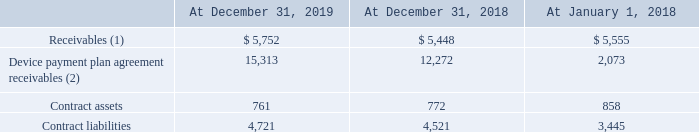Accounts receivable and contract balances
The timing of revenue recognition may differ from the time of billing to customers. Receivables presented in the balance sheet represent an unconditional right to consideration.
Contract balances represent amounts from an arrangement when either the performance obligation has been satisfied by transferring goods and/or services to the customer in advance of receiving all or partial consideration for such goods and/or services from the customer, or the customer has made payment in advance of obtaining control of the goods and/or services promised to the customer in the contract.
Contract assets primarily relate to rights to consideration for goods and/or services provided to the customers but for which there is not an unconditional right at the reporting date. Under a fixed-term plan, the total contract revenue is allocated between wireless services and equipment revenues, as discussed above.
In conjunction with these arrangements, a contract asset is created, which represents the difference between the amount of equipment revenue recognized upon sale and the amount of consideration received from the customer. The contract asset is recognized as accounts receivable as wireless services are provided and billed. The right to bill the customer is

obtained as service is provided over time, which results in the right to the payment being unconditional.
The contract asset balances are presented in the balance sheets as prepaid expenses and other, and other assets - net. Contract assets are assessed for impairment on an annual basis and an impairment charge is recognized to the extent the carrying amount is not recoverable. The impairment charge related to contract assets was insignificant for the years ended December 31, 2019 and 2018.
Increases in the contract asset balances were primarily due to new contracts and increases in sales promotions recognized upfront, driven by customer activity related to wireless services, while decreases were due to reclassifications to accounts receivable due to billings on the existing contracts and insignificant impairment charges.
Contract liabilities arise when customers are billed and consideration is received in advance of providing the goods and/or services promised in the contract. The majority of the contract liability at each year end is recognized during the following year as these contract liabilities primarily relate to advanced billing of fixed monthly fees for service that are recognized within the following month when services are provided to the customer.
The contract liability balances are presented in the balance sheet as contract liabilities and other, and other liabilities. Increases in contract liabilities were primarily due to increases in sales promotions recognized over time and upfront fees, as well as increases in deferred revenue related to advanced billings, while decreases in contract liabilities were primarily due to the satisfaction of performance obligations related to wireless services.
The balance of receivables from contracts with customers, contract assets and contract liabilities recorded in the balance sheet were as follows:
(1) Balances do not include receivables related to the following contracts: leasing arrangements (such as towers) and the interest on equipment financed on a device payment plan agreement when sold to the customer by an authorized agent. (2) Included in device payment plan agreement receivables presented in Device Payment Plans Note. Balances do not include receivables related to contracts completed prior to January 1, 2018 and receivables derived from the sale of equipment on a device payment plan through an authorized agent.
What is contract balances? Amounts from an arrangement when either the performance obligation has been satisfied by transferring goods and/or services to the customer in advance of receiving all or partial consideration for such goods and/or services from the customer, or the customer has made payment in advance of obtaining control of the goods and/or services promised to the customer in the contract. What are contract assets related to? Primarily relate to rights to consideration for goods and/or services provided to the customers but for which there is not an unconditional right at the reporting date. Where are the contract asset balances presented? The contract asset balances are presented in the balance sheets as prepaid expenses and other, and other assets - net. What is the increase / (decrease) in the receivables from 31 December 2018 to 31 December 2019? 5,752 - 5,448
Answer: 304. What is the average contract assets for years ended 2018 and 2019? (761 + 772) / 2
Answer: 766.5. What was the increase / (decrease) in contract liabilities from December 2018 to December 2019? 4,721 - 4,521
Answer: 200. 